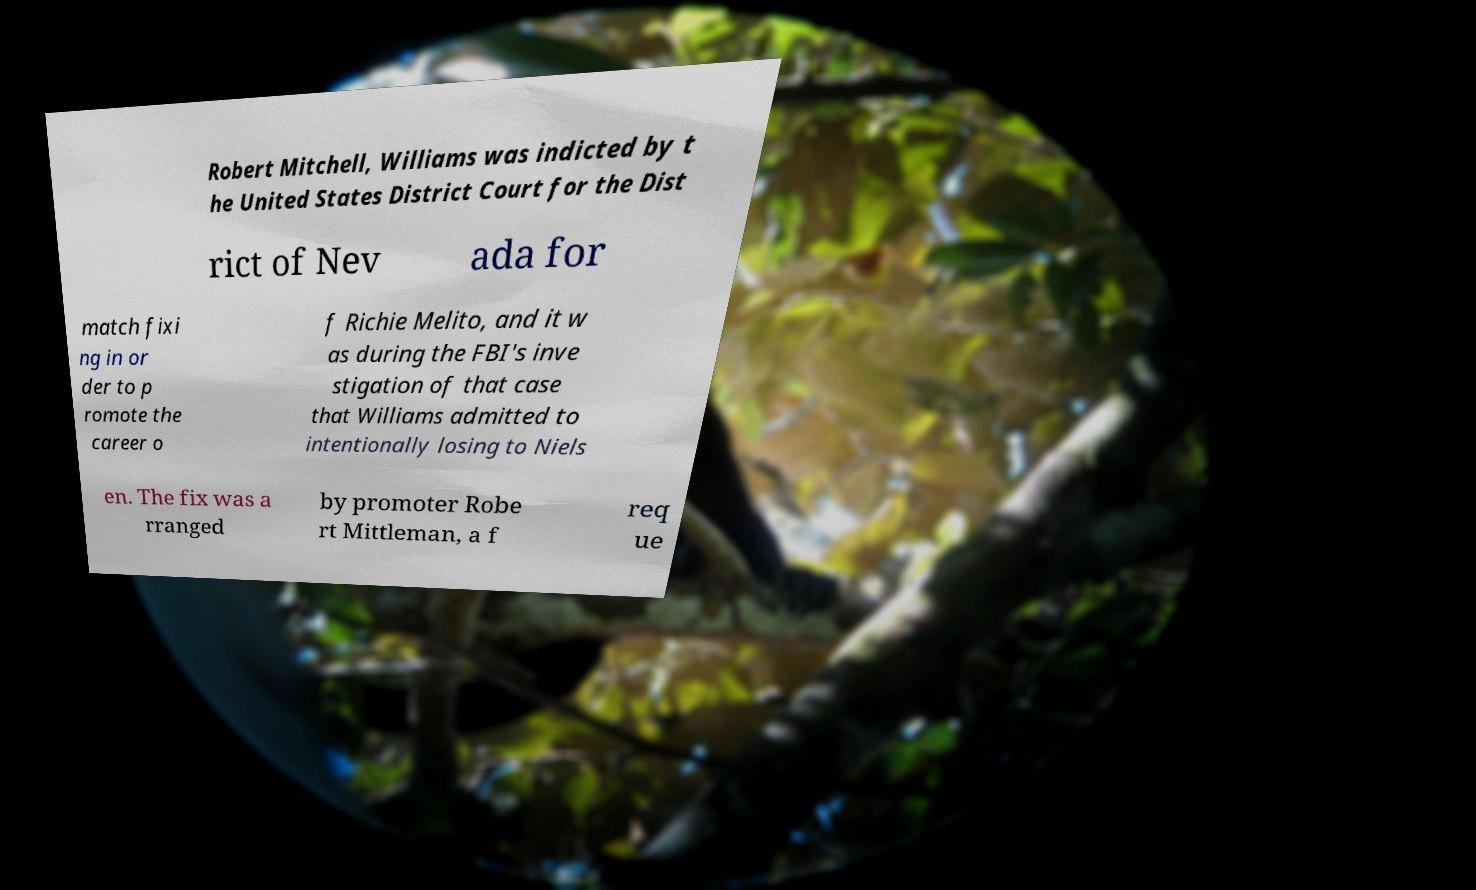I need the written content from this picture converted into text. Can you do that? Robert Mitchell, Williams was indicted by t he United States District Court for the Dist rict of Nev ada for match fixi ng in or der to p romote the career o f Richie Melito, and it w as during the FBI's inve stigation of that case that Williams admitted to intentionally losing to Niels en. The fix was a rranged by promoter Robe rt Mittleman, a f req ue 